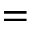<formula> <loc_0><loc_0><loc_500><loc_500>=</formula> 